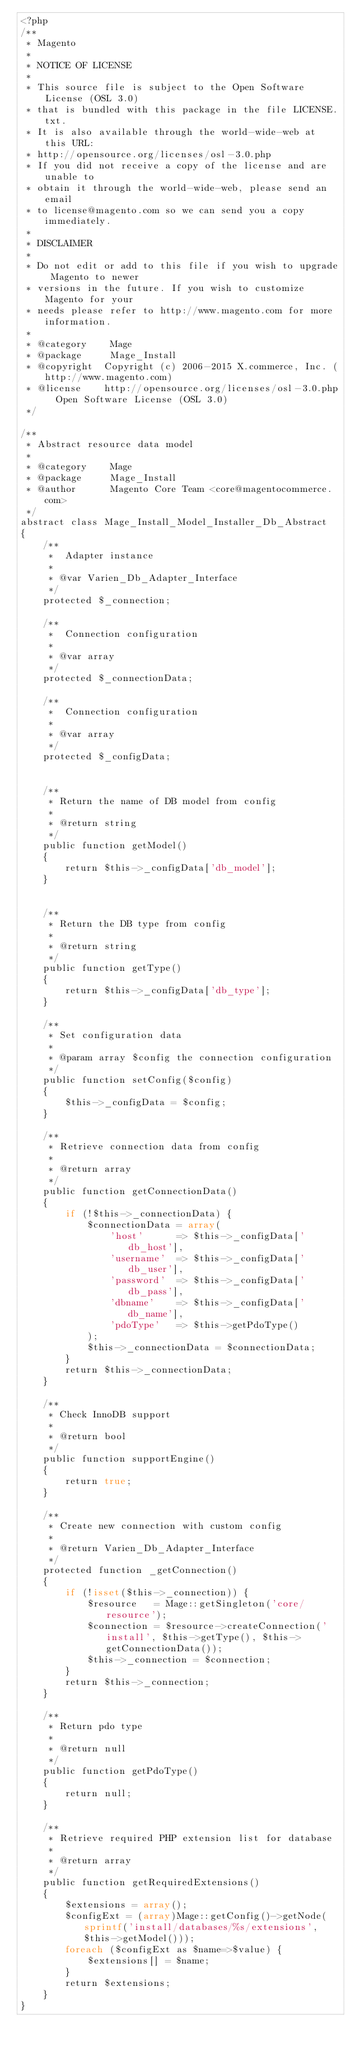Convert code to text. <code><loc_0><loc_0><loc_500><loc_500><_PHP_><?php
/**
 * Magento
 *
 * NOTICE OF LICENSE
 *
 * This source file is subject to the Open Software License (OSL 3.0)
 * that is bundled with this package in the file LICENSE.txt.
 * It is also available through the world-wide-web at this URL:
 * http://opensource.org/licenses/osl-3.0.php
 * If you did not receive a copy of the license and are unable to
 * obtain it through the world-wide-web, please send an email
 * to license@magento.com so we can send you a copy immediately.
 *
 * DISCLAIMER
 *
 * Do not edit or add to this file if you wish to upgrade Magento to newer
 * versions in the future. If you wish to customize Magento for your
 * needs please refer to http://www.magento.com for more information.
 *
 * @category    Mage
 * @package     Mage_Install
 * @copyright  Copyright (c) 2006-2015 X.commerce, Inc. (http://www.magento.com)
 * @license    http://opensource.org/licenses/osl-3.0.php  Open Software License (OSL 3.0)
 */

/**
 * Abstract resource data model
 *
 * @category    Mage
 * @package     Mage_Install
 * @author      Magento Core Team <core@magentocommerce.com>
 */
abstract class Mage_Install_Model_Installer_Db_Abstract
{
    /**
     *  Adapter instance
     *
     * @var Varien_Db_Adapter_Interface
     */
    protected $_connection;

    /**
     *  Connection configuration
     *
     * @var array
     */
    protected $_connectionData;

    /**
     *  Connection configuration
     *
     * @var array
     */
    protected $_configData;


    /**
     * Return the name of DB model from config
     *
     * @return string
     */
    public function getModel()
    {
        return $this->_configData['db_model'];
    }


    /**
     * Return the DB type from config
     *
     * @return string
     */
    public function getType()
    {
        return $this->_configData['db_type'];
    }

    /**
     * Set configuration data
     *
     * @param array $config the connection configuration
     */
    public function setConfig($config)
    {
        $this->_configData = $config;
    }

    /**
     * Retrieve connection data from config
     *
     * @return array
     */
    public function getConnectionData()
    {
        if (!$this->_connectionData) {
            $connectionData = array(
                'host'      => $this->_configData['db_host'],
                'username'  => $this->_configData['db_user'],
                'password'  => $this->_configData['db_pass'],
                'dbname'    => $this->_configData['db_name'],
                'pdoType'   => $this->getPdoType()
            );
            $this->_connectionData = $connectionData;
        }
        return $this->_connectionData;
    }

    /**
     * Check InnoDB support
     *
     * @return bool
     */
    public function supportEngine()
    {
        return true;
    }

    /**
     * Create new connection with custom config
     *
     * @return Varien_Db_Adapter_Interface
     */
    protected function _getConnection()
    {
        if (!isset($this->_connection)) {
            $resource   = Mage::getSingleton('core/resource');
            $connection = $resource->createConnection('install', $this->getType(), $this->getConnectionData());
            $this->_connection = $connection;
        }
        return $this->_connection;
    }

    /**
     * Return pdo type
     *
     * @return null
     */
    public function getPdoType()
    {
        return null;
    }

    /**
     * Retrieve required PHP extension list for database
     *
     * @return array
     */
    public function getRequiredExtensions()
    {
        $extensions = array();
        $configExt = (array)Mage::getConfig()->getNode(sprintf('install/databases/%s/extensions', $this->getModel()));
        foreach ($configExt as $name=>$value) {
            $extensions[] = $name;
        }
        return $extensions;
    }
}
</code> 